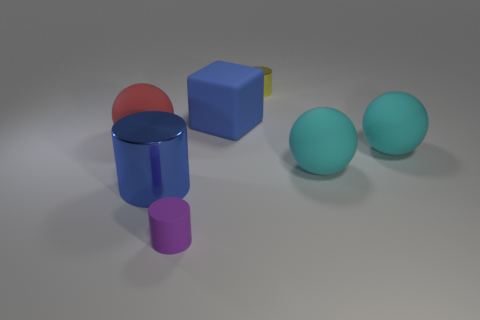Do the large blue matte thing that is on the left side of the yellow metallic thing and the small thing that is in front of the large blue metal thing have the same shape?
Offer a terse response. No. Are there any purple things that have the same material as the blue cylinder?
Your answer should be compact. No. Does the tiny thing to the right of the blue block have the same material as the tiny purple object?
Your answer should be compact. No. Are there more purple cylinders that are behind the small purple matte cylinder than cyan things behind the blue cube?
Keep it short and to the point. No. What color is the metal cylinder that is the same size as the blue block?
Ensure brevity in your answer.  Blue. Are there any rubber spheres of the same color as the big rubber block?
Offer a terse response. No. Do the tiny thing in front of the red rubber ball and the big sphere on the left side of the big blue shiny cylinder have the same color?
Your answer should be very brief. No. What material is the big blue object that is in front of the big red rubber ball?
Offer a terse response. Metal. There is a big cube that is the same material as the small purple object; what is its color?
Your response must be concise. Blue. What number of yellow metal objects have the same size as the purple cylinder?
Provide a succinct answer. 1. 